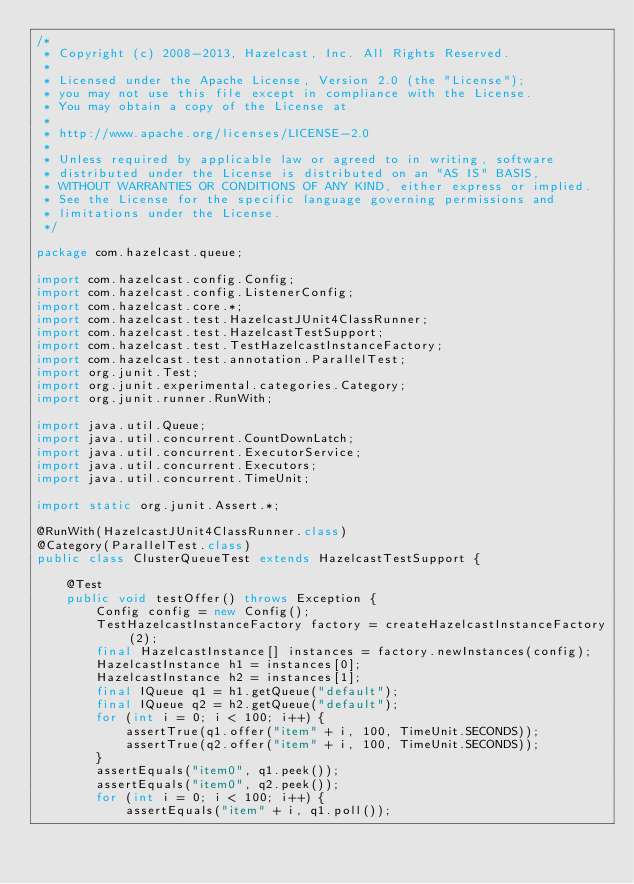<code> <loc_0><loc_0><loc_500><loc_500><_Java_>/*
 * Copyright (c) 2008-2013, Hazelcast, Inc. All Rights Reserved.
 *
 * Licensed under the Apache License, Version 2.0 (the "License");
 * you may not use this file except in compliance with the License.
 * You may obtain a copy of the License at
 *
 * http://www.apache.org/licenses/LICENSE-2.0
 *
 * Unless required by applicable law or agreed to in writing, software
 * distributed under the License is distributed on an "AS IS" BASIS,
 * WITHOUT WARRANTIES OR CONDITIONS OF ANY KIND, either express or implied.
 * See the License for the specific language governing permissions and
 * limitations under the License.
 */

package com.hazelcast.queue;

import com.hazelcast.config.Config;
import com.hazelcast.config.ListenerConfig;
import com.hazelcast.core.*;
import com.hazelcast.test.HazelcastJUnit4ClassRunner;
import com.hazelcast.test.HazelcastTestSupport;
import com.hazelcast.test.TestHazelcastInstanceFactory;
import com.hazelcast.test.annotation.ParallelTest;
import org.junit.Test;
import org.junit.experimental.categories.Category;
import org.junit.runner.RunWith;

import java.util.Queue;
import java.util.concurrent.CountDownLatch;
import java.util.concurrent.ExecutorService;
import java.util.concurrent.Executors;
import java.util.concurrent.TimeUnit;

import static org.junit.Assert.*;

@RunWith(HazelcastJUnit4ClassRunner.class)
@Category(ParallelTest.class)
public class ClusterQueueTest extends HazelcastTestSupport {

    @Test
    public void testOffer() throws Exception {
        Config config = new Config();
        TestHazelcastInstanceFactory factory = createHazelcastInstanceFactory(2);
        final HazelcastInstance[] instances = factory.newInstances(config);
        HazelcastInstance h1 = instances[0];
        HazelcastInstance h2 = instances[1];
        final IQueue q1 = h1.getQueue("default");
        final IQueue q2 = h2.getQueue("default");
        for (int i = 0; i < 100; i++) {
            assertTrue(q1.offer("item" + i, 100, TimeUnit.SECONDS));
            assertTrue(q2.offer("item" + i, 100, TimeUnit.SECONDS));
        }
        assertEquals("item0", q1.peek());
        assertEquals("item0", q2.peek());
        for (int i = 0; i < 100; i++) {
            assertEquals("item" + i, q1.poll());</code> 